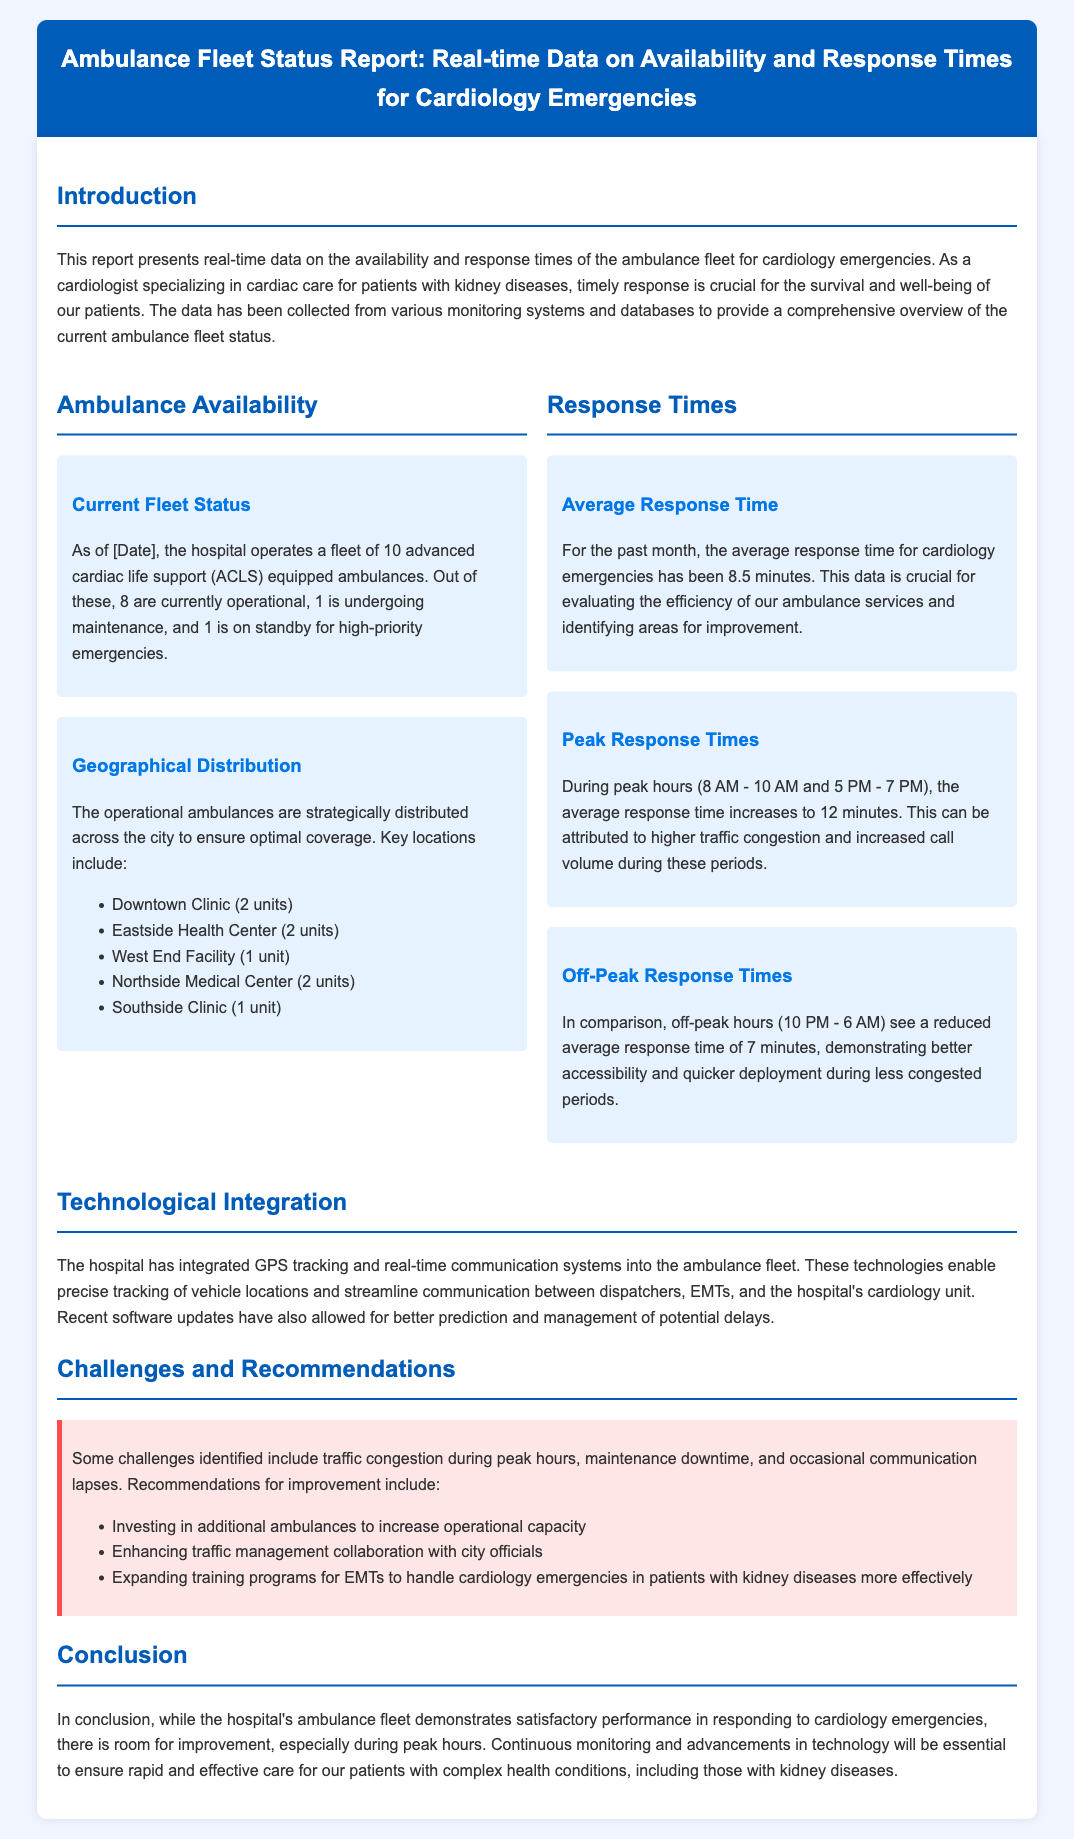What is the total number of ambulances in the fleet? The document states that the hospital operates a fleet of 10 advanced cardiac life support (ACLS) equipped ambulances.
Answer: 10 How many ambulances are operational currently? The report mentions that out of the 10 ambulances, 8 are currently operational.
Answer: 8 What is the average response time for cardiology emergencies? According to the document, the average response time for the past month has been 8.5 minutes.
Answer: 8.5 minutes What is the average response time during peak hours? The document states that during peak hours (8 AM - 10 AM and 5 PM - 7 PM), the average response time increases to 12 minutes.
Answer: 12 minutes Where is one of the ambulances located? The report lists locations where ambulances are distributed, such as Downtown Clinic, Eastside Health Center, or others.
Answer: Downtown Clinic What is one identified challenge mentioned in the report? The document highlights traffic congestion during peak hours as one of the challenges faced by the ambulance fleet.
Answer: Traffic congestion What technology has been integrated into the ambulance fleet? The report indicates that GPS tracking and real-time communication systems have been integrated into the fleet.
Answer: GPS tracking What recommendation is made to enhance ambulance service capacity? The document recommends investing in additional ambulances to increase operational capacity.
Answer: Additional ambulances What time frame is considered off-peak hours? The report indicates that off-peak hours are from 10 PM to 6 AM.
Answer: 10 PM - 6 AM 